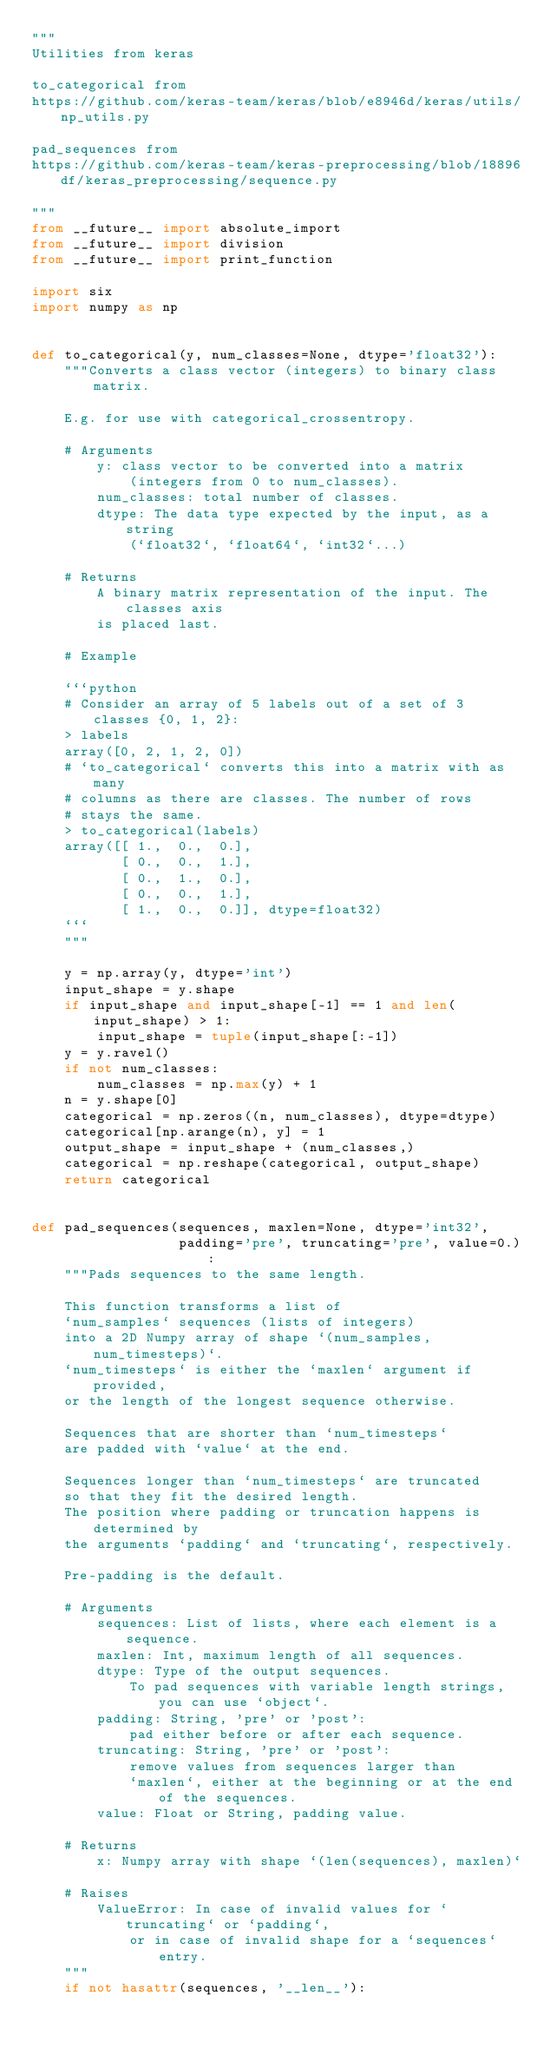<code> <loc_0><loc_0><loc_500><loc_500><_Python_>"""
Utilities from keras

to_categorical from
https://github.com/keras-team/keras/blob/e8946d/keras/utils/np_utils.py

pad_sequences from
https://github.com/keras-team/keras-preprocessing/blob/18896df/keras_preprocessing/sequence.py

"""
from __future__ import absolute_import
from __future__ import division
from __future__ import print_function

import six
import numpy as np


def to_categorical(y, num_classes=None, dtype='float32'):
    """Converts a class vector (integers) to binary class matrix.

    E.g. for use with categorical_crossentropy.

    # Arguments
        y: class vector to be converted into a matrix
            (integers from 0 to num_classes).
        num_classes: total number of classes.
        dtype: The data type expected by the input, as a string
            (`float32`, `float64`, `int32`...)

    # Returns
        A binary matrix representation of the input. The classes axis
        is placed last.

    # Example

    ```python
    # Consider an array of 5 labels out of a set of 3 classes {0, 1, 2}:
    > labels
    array([0, 2, 1, 2, 0])
    # `to_categorical` converts this into a matrix with as many
    # columns as there are classes. The number of rows
    # stays the same.
    > to_categorical(labels)
    array([[ 1.,  0.,  0.],
           [ 0.,  0.,  1.],
           [ 0.,  1.,  0.],
           [ 0.,  0.,  1.],
           [ 1.,  0.,  0.]], dtype=float32)
    ```
    """

    y = np.array(y, dtype='int')
    input_shape = y.shape
    if input_shape and input_shape[-1] == 1 and len(input_shape) > 1:
        input_shape = tuple(input_shape[:-1])
    y = y.ravel()
    if not num_classes:
        num_classes = np.max(y) + 1
    n = y.shape[0]
    categorical = np.zeros((n, num_classes), dtype=dtype)
    categorical[np.arange(n), y] = 1
    output_shape = input_shape + (num_classes,)
    categorical = np.reshape(categorical, output_shape)
    return categorical


def pad_sequences(sequences, maxlen=None, dtype='int32',
                  padding='pre', truncating='pre', value=0.):
    """Pads sequences to the same length.

    This function transforms a list of
    `num_samples` sequences (lists of integers)
    into a 2D Numpy array of shape `(num_samples, num_timesteps)`.
    `num_timesteps` is either the `maxlen` argument if provided,
    or the length of the longest sequence otherwise.

    Sequences that are shorter than `num_timesteps`
    are padded with `value` at the end.

    Sequences longer than `num_timesteps` are truncated
    so that they fit the desired length.
    The position where padding or truncation happens is determined by
    the arguments `padding` and `truncating`, respectively.

    Pre-padding is the default.

    # Arguments
        sequences: List of lists, where each element is a sequence.
        maxlen: Int, maximum length of all sequences.
        dtype: Type of the output sequences.
            To pad sequences with variable length strings, you can use `object`.
        padding: String, 'pre' or 'post':
            pad either before or after each sequence.
        truncating: String, 'pre' or 'post':
            remove values from sequences larger than
            `maxlen`, either at the beginning or at the end of the sequences.
        value: Float or String, padding value.

    # Returns
        x: Numpy array with shape `(len(sequences), maxlen)`

    # Raises
        ValueError: In case of invalid values for `truncating` or `padding`,
            or in case of invalid shape for a `sequences` entry.
    """
    if not hasattr(sequences, '__len__'):</code> 